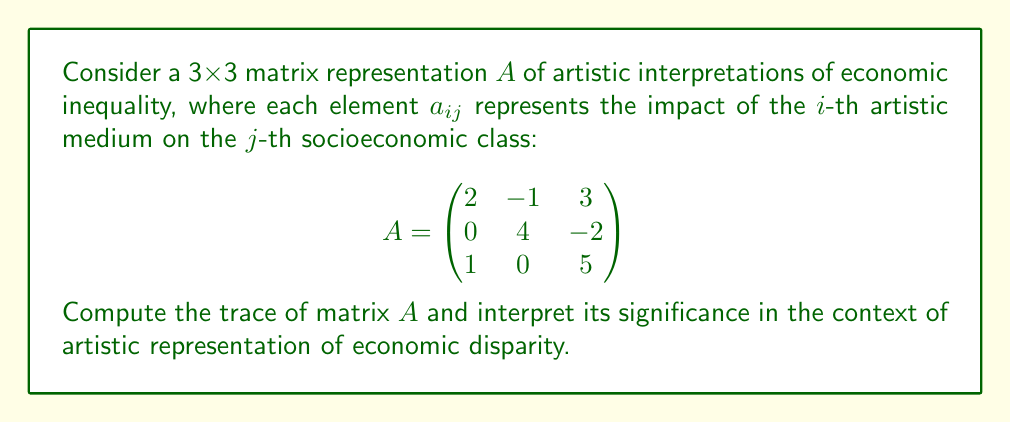Can you answer this question? To solve this problem, we'll follow these steps:

1) Recall that the trace of a square matrix is defined as the sum of the elements on its main diagonal (from top-left to bottom-right).

2) For a matrix $A = (a_{ij})$, the trace is given by:

   $\text{tr}(A) = \sum_{i=1}^n a_{ii}$

   where $n$ is the dimension of the square matrix.

3) In our 3x3 matrix $A$, the diagonal elements are:
   $a_{11} = 2$
   $a_{22} = 4$
   $a_{33} = 5$

4) Sum these diagonal elements:

   $\text{tr}(A) = 2 + 4 + 5 = 11$

5) Interpretation: In the context of artistic representations of economic inequality, the trace (11) represents the cumulative direct impact of each artistic medium on its corresponding socioeconomic class. A positive trace suggests that, overall, artistic interpretations tend to reinforce or highlight existing economic disparities rather than challenge them.

This interpretation aligns with the given persona's critique of privilege masking as poverty, as it implies that artistic representations might inadvertently perpetuate economic inequality rather than exposing or subverting it.
Answer: $\text{tr}(A) = 11$ 